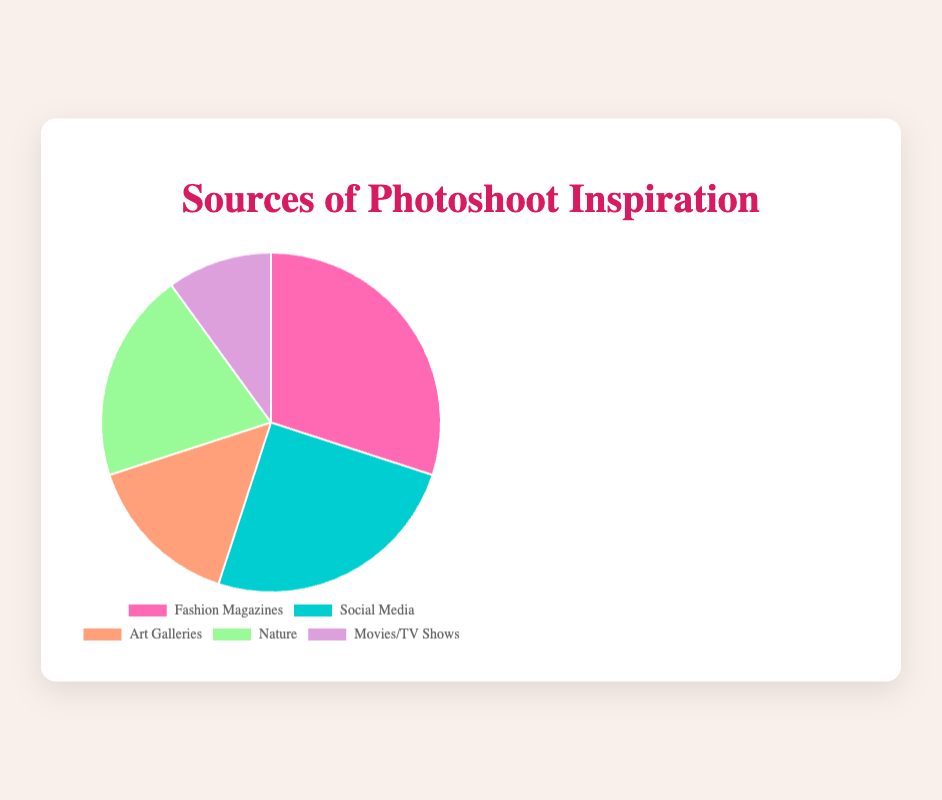What is the largest source of photoshoot inspiration? The figure shows that "Fashion Magazines" occupy the largest portion of the pie chart. By looking at the label and percentage, which is 30%, it can be concluded that "Fashion Magazines" is the largest source.
Answer: Fashion Magazines Which two sources together account for half of the inspiration sources? By adding the percentages of different sources, "Fashion Magazines" (30%) and "Social Media" (25%) sum up to 55%, which is more than half. Another possible combination is "Fashion Magazines" (30%) and "Nature" (20%), which sum up to 50%.
Answer: Fashion Magazines and Nature How much more popular is "Nature" compared to "Movies/TV Shows"? To find the difference, subtract the percentage of "Movies/TV Shows" (10%) from "Nature" (20%): 20% - 10% = 10%. Thus, "Nature" is 10% more popular than "Movies/TV Shows".
Answer: 10% What is the sum of the percentages for "Art Galleries" and "Movies/TV Shows"? The percentages for "Art Galleries" and "Movies/TV Shows" are 15% and 10% respectively. Adding them together: 15% + 10% = 25%.
Answer: 25% Compare the popularity of "Social Media" and "Nature". Which one is more popular and by how much? "Social Media" has a percentage of 25%, while "Nature" has 20%. Thus, "Social Media" is more popular. The difference is 25% - 20% = 5%.
Answer: Social Media by 5% Identify the color of the segment representing "Art Galleries". The pie chart segment for "Art Galleries" is represented visually with the color orange.
Answer: Orange If you combine "Fashion Magazines" and "Social Media", what percentage of inspiration sources do they represent? Adding the percentages for "Fashion Magazines" (30%) and "Social Media" (25%) gives: 30% + 25% = 55%.
Answer: 55% Which sources combined make up the smallest half of the pie chart? To find which sources make up the smallest half, add the percentages of sources ordered from smallest to largest: "Movies/TV Shows" (10%) + "Art Galleries" (15%) + "Nature" (20%) = 45%. These sources combined make up the smallest portion less than half.
Answer: Movies/TV Shows, Art Galleries, and Nature How does the popularity of "Fashion Magazines" compare with the total of "Art Galleries" and "Movies/TV Shows"? "Fashion Magazines" have a percentage of 30%, while adding "Art Galleries" (15%) and "Movies/TV Shows" (10%) gives: 15% + 10% = 25%. "Fashion Magazines" are more popular by 30% - 25% = 5%.
Answer: Fashion Magazines by 5% 